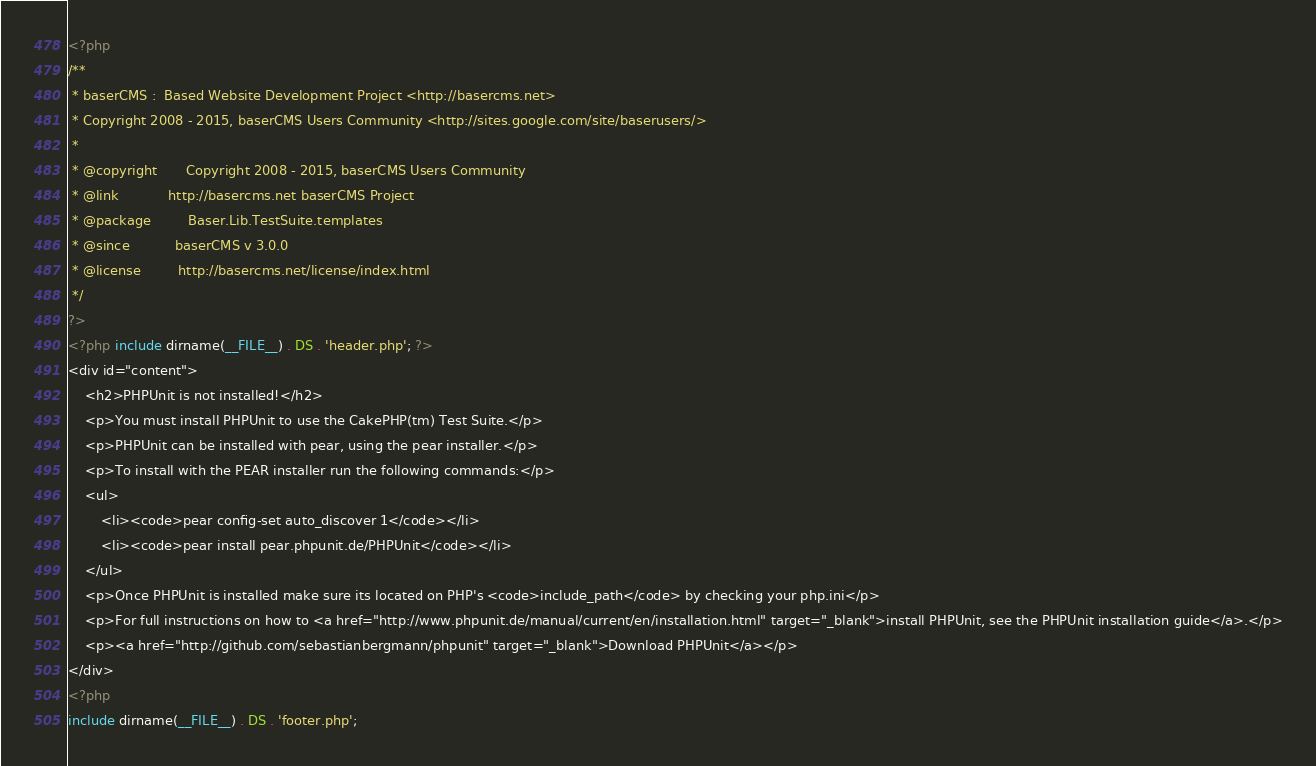Convert code to text. <code><loc_0><loc_0><loc_500><loc_500><_PHP_><?php
/**
 * baserCMS :  Based Website Development Project <http://basercms.net>
 * Copyright 2008 - 2015, baserCMS Users Community <http://sites.google.com/site/baserusers/>
 *
 * @copyright		Copyright 2008 - 2015, baserCMS Users Community
 * @link			http://basercms.net baserCMS Project
 * @package			Baser.Lib.TestSuite.templates
 * @since			baserCMS v 3.0.0
 * @license			http://basercms.net/license/index.html
 */
?>
<?php include dirname(__FILE__) . DS . 'header.php'; ?>
<div id="content">
	<h2>PHPUnit is not installed!</h2>
	<p>You must install PHPUnit to use the CakePHP(tm) Test Suite.</p>
	<p>PHPUnit can be installed with pear, using the pear installer.</p>
	<p>To install with the PEAR installer run the following commands:</p>
	<ul>
		<li><code>pear config-set auto_discover 1</code></li>
		<li><code>pear install pear.phpunit.de/PHPUnit</code></li>
	</ul>
	<p>Once PHPUnit is installed make sure its located on PHP's <code>include_path</code> by checking your php.ini</p>
	<p>For full instructions on how to <a href="http://www.phpunit.de/manual/current/en/installation.html" target="_blank">install PHPUnit, see the PHPUnit installation guide</a>.</p>
	<p><a href="http://github.com/sebastianbergmann/phpunit" target="_blank">Download PHPUnit</a></p>
</div>
<?php
include dirname(__FILE__) . DS . 'footer.php';
</code> 